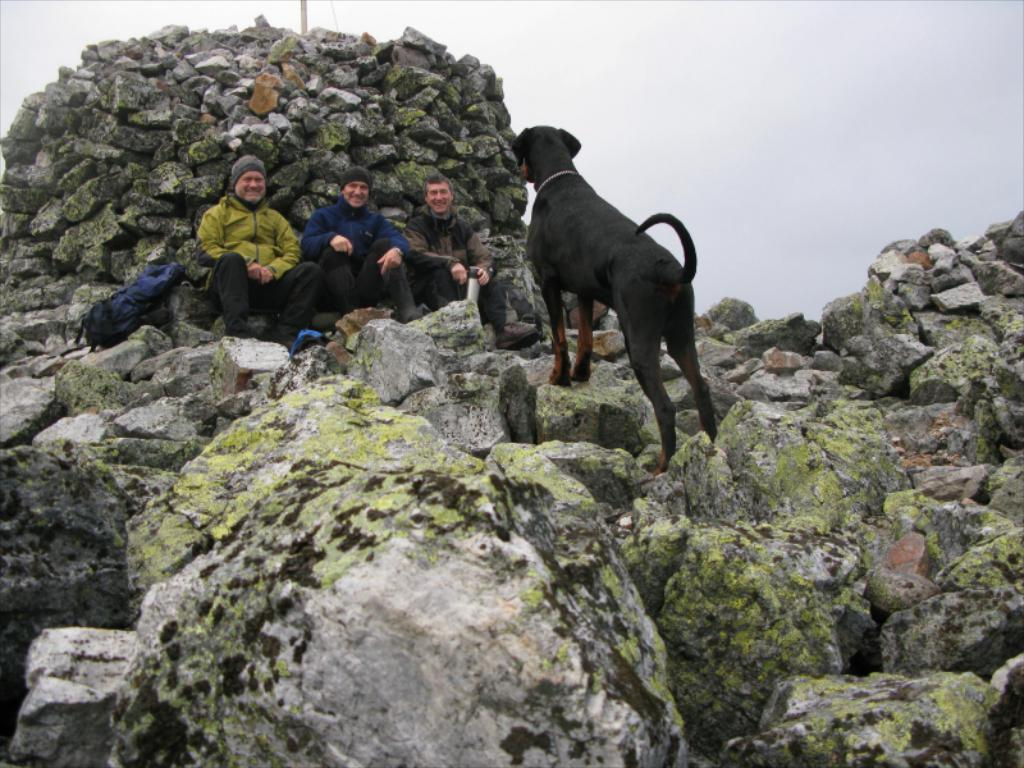How many people are in the image? There are three persons in the image. What object can be seen in the image besides the people? There is a bag and a dog visible in the image. What type of terrain is present in the image? There are rocks visible in the image, indicating a rocky terrain. What is visible in the background of the image? The sky is visible in the image. What type of wool is the dog wearing in the image? There is no wool or clothing visible on the dog in the image. How does the ice form on the rocks in the image? There is no ice present in the image; the rocks are dry. 